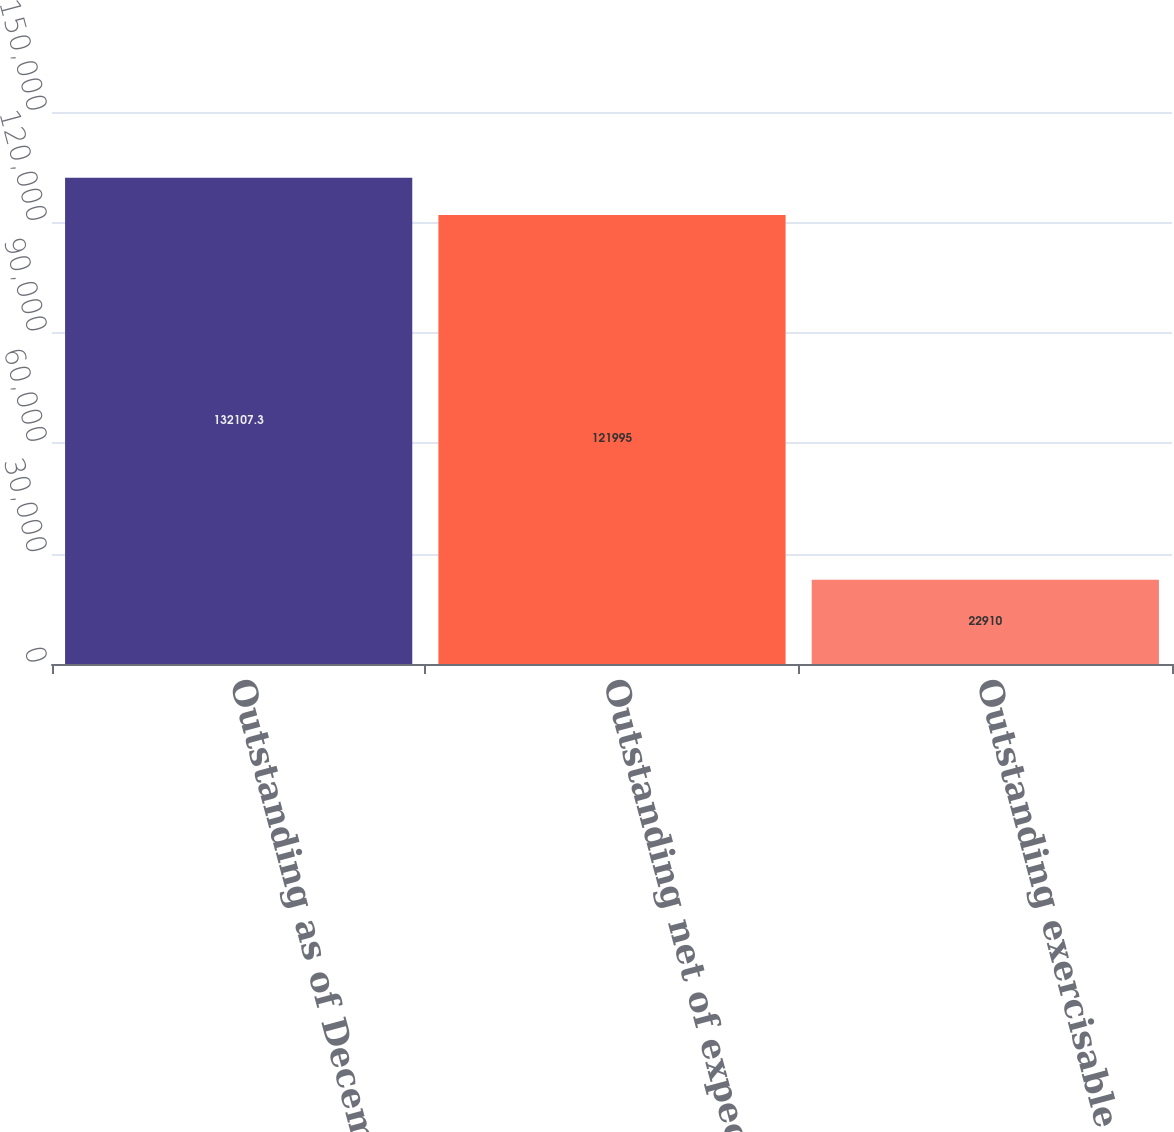Convert chart. <chart><loc_0><loc_0><loc_500><loc_500><bar_chart><fcel>Outstanding as of December 31<fcel>Outstanding net of expected<fcel>Outstanding exercisable<nl><fcel>132107<fcel>121995<fcel>22910<nl></chart> 